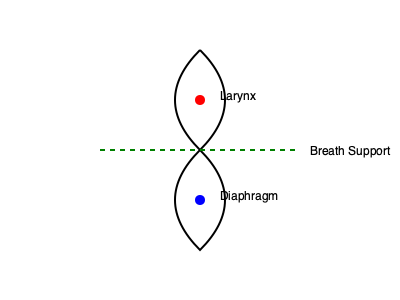In the diagram above, which physiological structure plays a crucial role in supporting breath control and vocal projection, and how does it contribute to effective vocal performance for both singing and acting? To answer this question, let's break down the key elements of vocal projection and breath control:

1. Diaphragm function:
   - The diaphragm, represented by the blue dot in the lower part of the diagram, is the primary muscle responsible for breathing.
   - It contracts and flattens during inhalation, creating negative pressure in the lungs to draw in air.
   - During exhalation, it relaxes and moves upward, helping to expel air.

2. Breath support:
   - The green dashed line represents breath support, which is crucial for both singing and acting.
   - Proper breath support involves controlled engagement of the diaphragm and abdominal muscles.
   - This control allows for sustained and consistent airflow, essential for maintaining vocal quality and projection.

3. Larynx involvement:
   - The larynx, represented by the red dot in the upper part of the diagram, houses the vocal folds.
   - While not directly responsible for breath control, its position and tension affect vocal quality and projection.

4. Contribution to vocal performance:
   - The diaphragm's controlled movement allows for precise management of air pressure and flow.
   - This control enables performers to:
     a) Sustain long phrases without running out of breath
     b) Vary vocal intensity and dynamics
     c) Maintain vocal quality throughout a performance
     d) Project their voice effectively, reaching the back of a theater or concert hall

5. Application in acting:
   - In acting, diaphragmatic breathing helps in:
     a) Emotional regulation and expression
     b) Voice modulation for different characters
     c) Maintaining vocal stamina during long performances

Given these factors, the diaphragm is the key structure in this diagram that plays a crucial role in supporting breath control and vocal projection, directly contributing to effective vocal performance in both singing and acting.
Answer: The diaphragm 